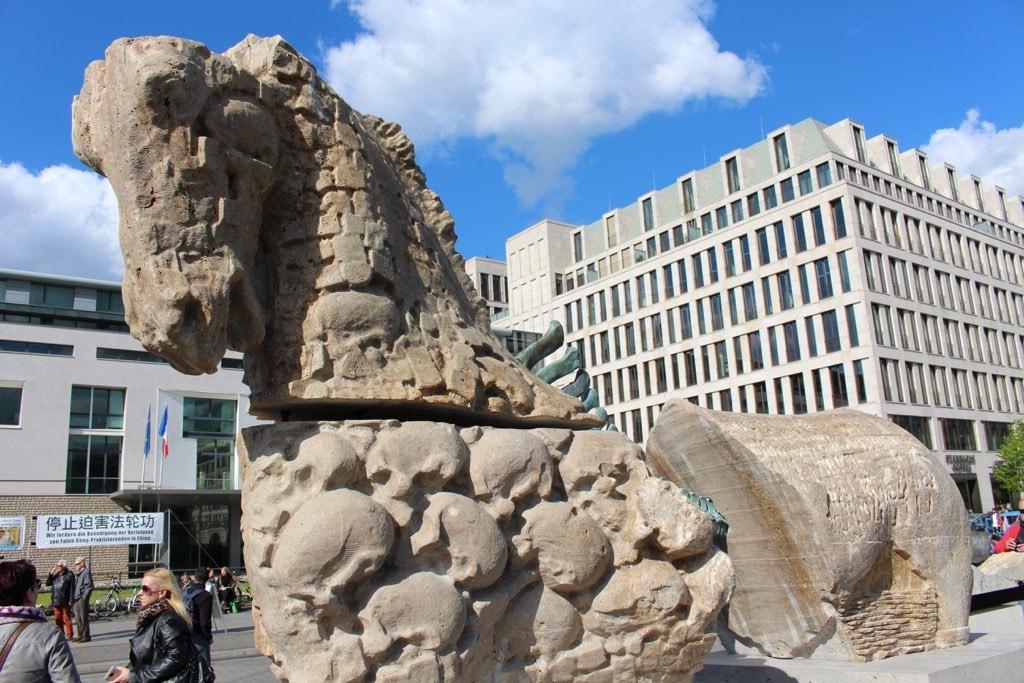Could you give a brief overview of what you see in this image? In front of the image there are rock structures. There are people standing on the road. There are banners, flags, cycles and a tree. In the background of the image there are buildings. At the top of the image there are clouds in the sky. 